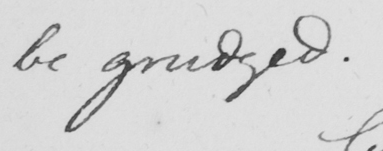What does this handwritten line say? be grudged . 